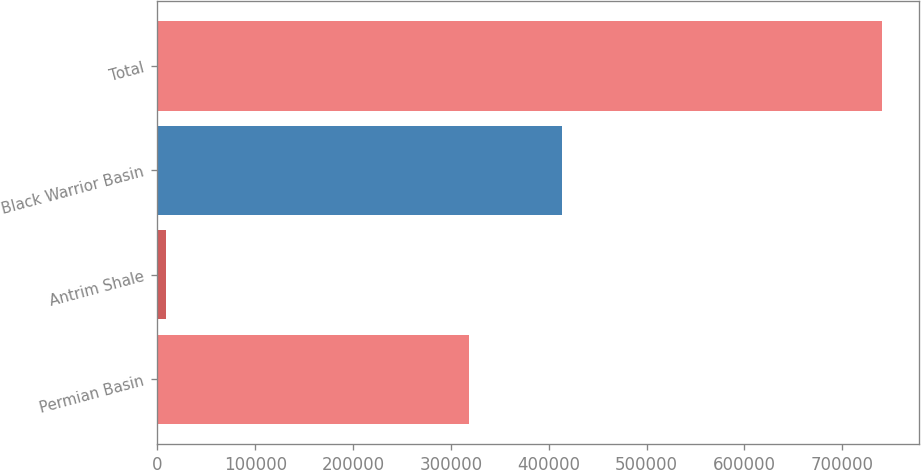<chart> <loc_0><loc_0><loc_500><loc_500><bar_chart><fcel>Permian Basin<fcel>Antrim Shale<fcel>Black Warrior Basin<fcel>Total<nl><fcel>318887<fcel>8262<fcel>413796<fcel>740945<nl></chart> 